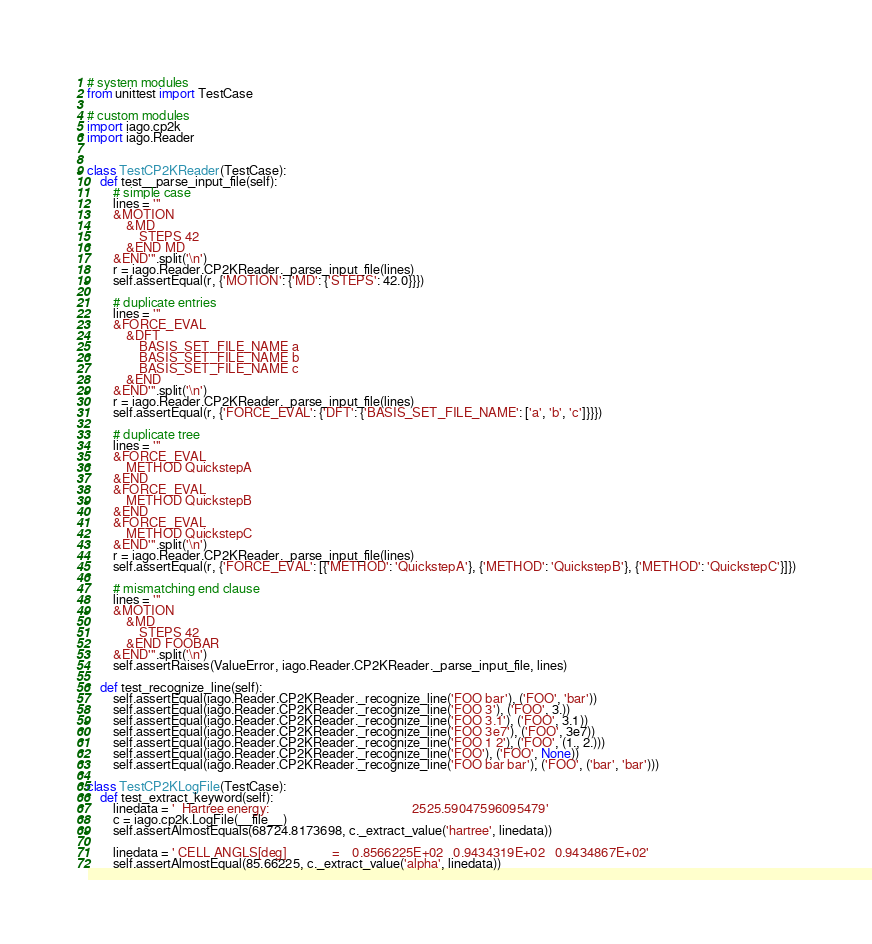Convert code to text. <code><loc_0><loc_0><loc_500><loc_500><_Python_># system modules
from unittest import TestCase

# custom modules
import iago.cp2k
import iago.Reader


class TestCP2KReader(TestCase):
	def test__parse_input_file(self):
		# simple case
		lines = '''
		&MOTION
			&MD
				STEPS 42
			&END MD
		&END'''.split('\n')
		r = iago.Reader.CP2KReader._parse_input_file(lines)
		self.assertEqual(r, {'MOTION': {'MD': {'STEPS': 42.0}}})

		# duplicate entries
		lines = '''
		&FORCE_EVAL
			&DFT
				BASIS_SET_FILE_NAME a
				BASIS_SET_FILE_NAME b
				BASIS_SET_FILE_NAME c
			&END
		&END'''.split('\n')
		r = iago.Reader.CP2KReader._parse_input_file(lines)
		self.assertEqual(r, {'FORCE_EVAL': {'DFT': {'BASIS_SET_FILE_NAME': ['a', 'b', 'c']}}})

		# duplicate tree
		lines = '''
		&FORCE_EVAL
			METHOD QuickstepA
		&END
		&FORCE_EVAL
			METHOD QuickstepB
		&END
		&FORCE_EVAL
			METHOD QuickstepC
		&END'''.split('\n')
		r = iago.Reader.CP2KReader._parse_input_file(lines)
		self.assertEqual(r, {'FORCE_EVAL': [{'METHOD': 'QuickstepA'}, {'METHOD': 'QuickstepB'}, {'METHOD': 'QuickstepC'}]})

		# mismatching end clause
		lines = '''
		&MOTION
			&MD
				STEPS 42
			&END FOOBAR
		&END'''.split('\n')
		self.assertRaises(ValueError, iago.Reader.CP2KReader._parse_input_file, lines)

	def test_recognize_line(self):
		self.assertEqual(iago.Reader.CP2KReader._recognize_line('FOO bar'), ('FOO', 'bar'))
		self.assertEqual(iago.Reader.CP2KReader._recognize_line('FOO 3'), ('FOO', 3.))
		self.assertEqual(iago.Reader.CP2KReader._recognize_line('FOO 3.1'), ('FOO', 3.1))
		self.assertEqual(iago.Reader.CP2KReader._recognize_line('FOO 3e7'), ('FOO', 3e7))
		self.assertEqual(iago.Reader.CP2KReader._recognize_line('FOO 1 2'), ('FOO', (1., 2.)))
		self.assertEqual(iago.Reader.CP2KReader._recognize_line('FOO'), ('FOO', None))
		self.assertEqual(iago.Reader.CP2KReader._recognize_line('FOO bar bar'), ('FOO', ('bar', 'bar')))

class TestCP2KLogFile(TestCase):
	def test_extract_keyword(self):
		linedata = '  Hartree energy:                                            2525.59047596095479'
		c = iago.cp2k.LogFile(__file__)
		self.assertAlmostEquals(68724.8173698, c._extract_value('hartree', linedata))

		linedata = ' CELL ANGLS[deg]              =    0.8566225E+02   0.9434319E+02   0.9434867E+02'
		self.assertAlmostEqual(85.66225, c._extract_value('alpha', linedata))</code> 